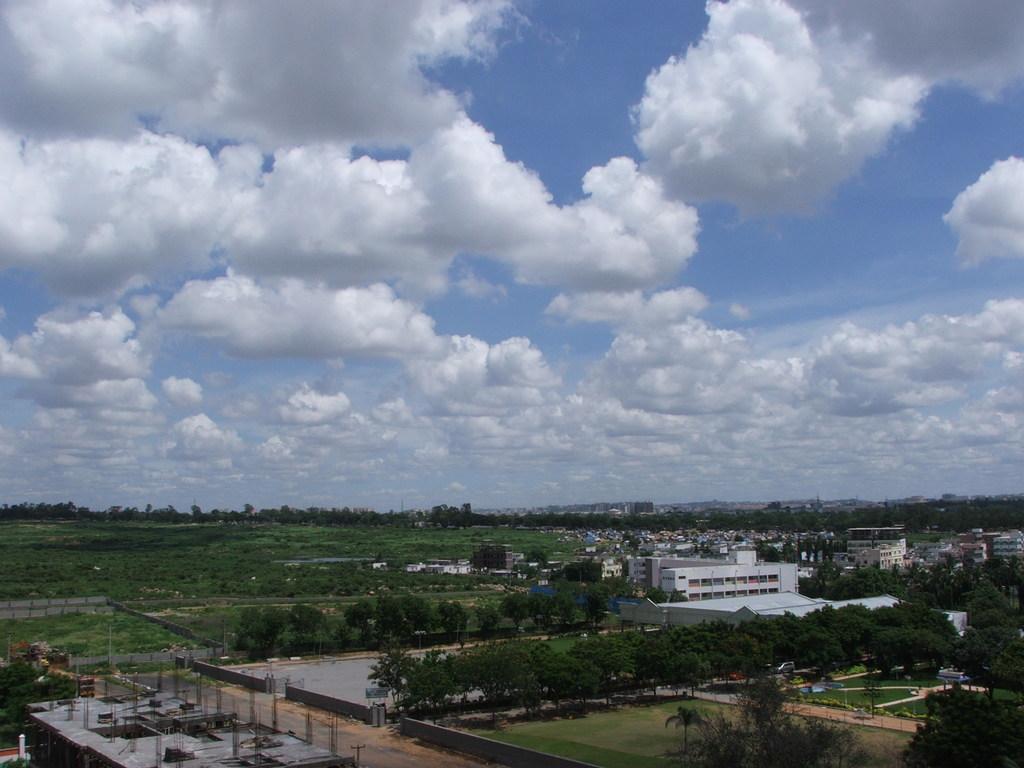Can you describe this image briefly? At the down there are trees and buildings, at the top it is the cloudy sky. 